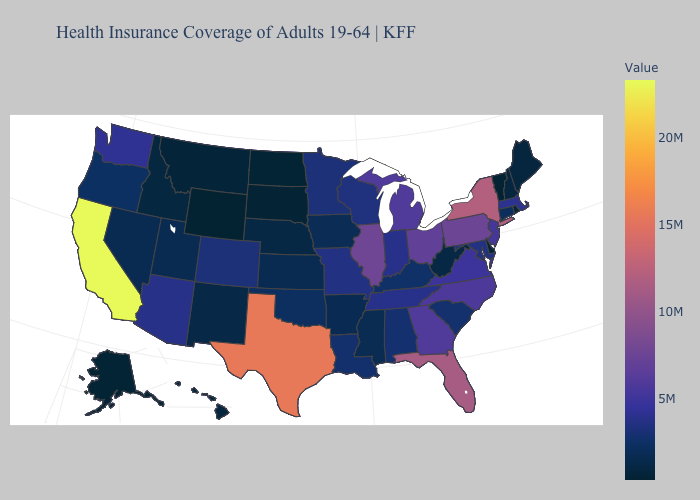Which states hav the highest value in the South?
Write a very short answer. Texas. Does New York have the highest value in the Northeast?
Answer briefly. Yes. Does the map have missing data?
Give a very brief answer. No. Which states have the lowest value in the MidWest?
Answer briefly. North Dakota. Among the states that border Massachusetts , which have the highest value?
Be succinct. New York. Does Wyoming have the lowest value in the USA?
Keep it brief. Yes. Does the map have missing data?
Quick response, please. No. 